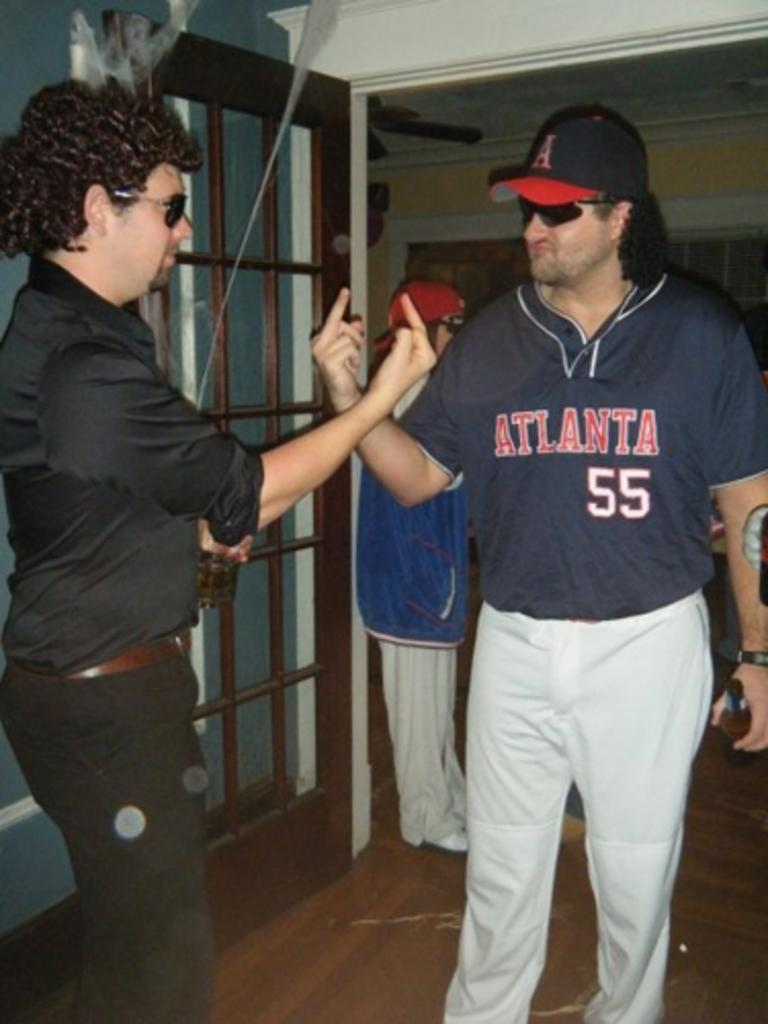<image>
Offer a succinct explanation of the picture presented. Man giving another man the middle finger while wearing a jersey that says 55 on it. 